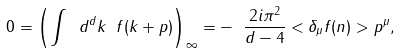Convert formula to latex. <formula><loc_0><loc_0><loc_500><loc_500>0 = \left ( \int \ d ^ { d } k \ f ( k + p ) \right ) _ { \infty } = - \ \frac { 2 i \pi ^ { 2 } } { d - 4 } < \delta _ { \mu } f ( n ) > p ^ { \mu } ,</formula> 